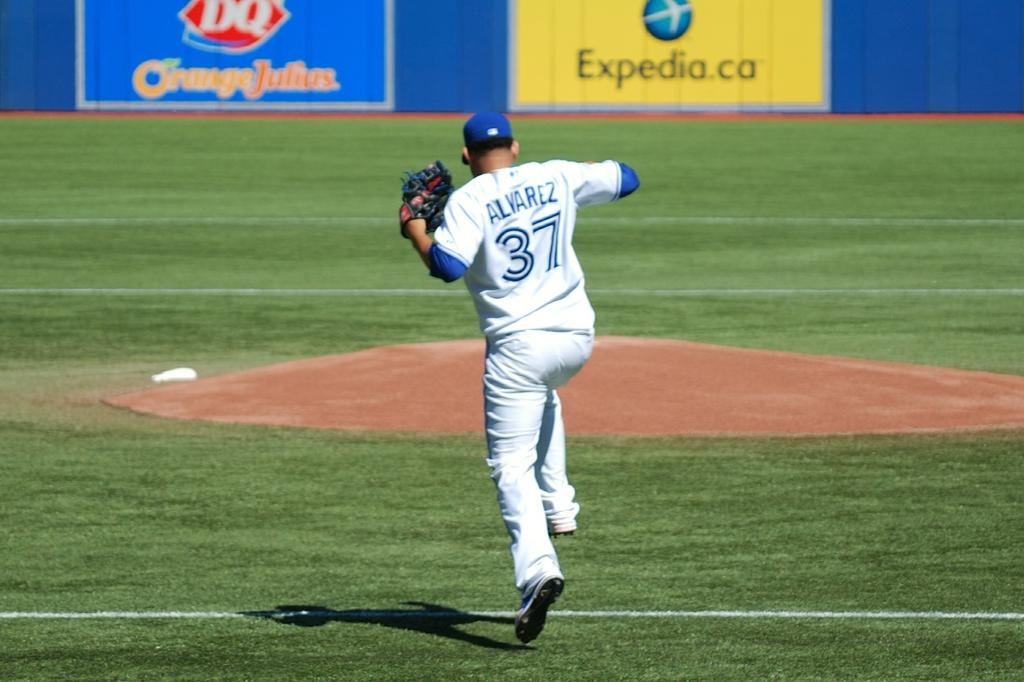<image>
Share a concise interpretation of the image provided. Player number 37 jumps up into the air on the field. 